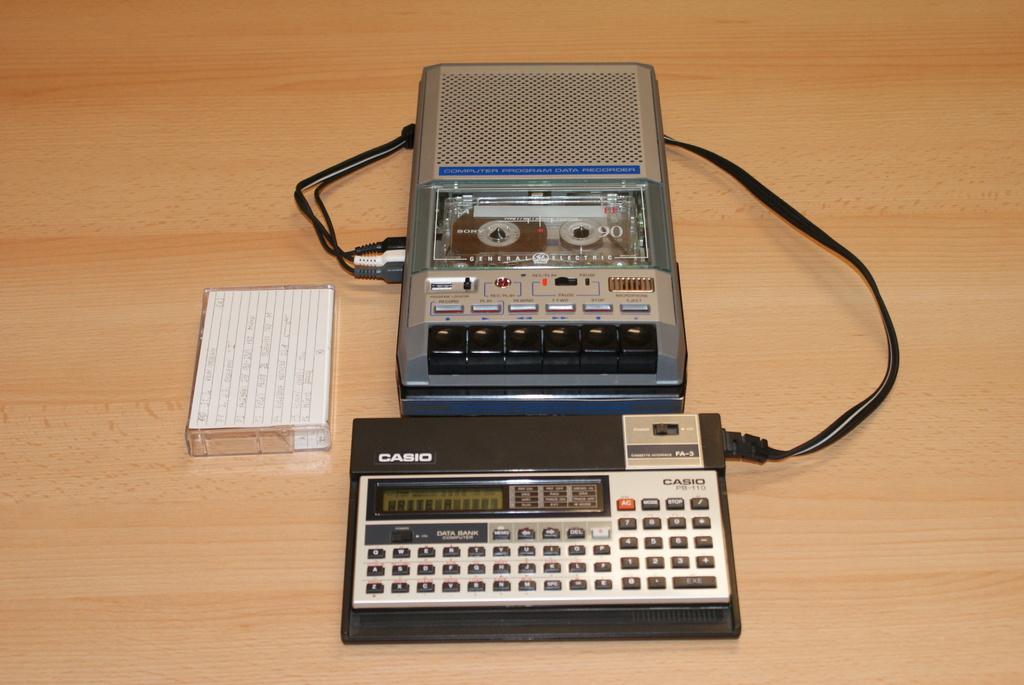What company made that machine?
Keep it short and to the point. Casio. 